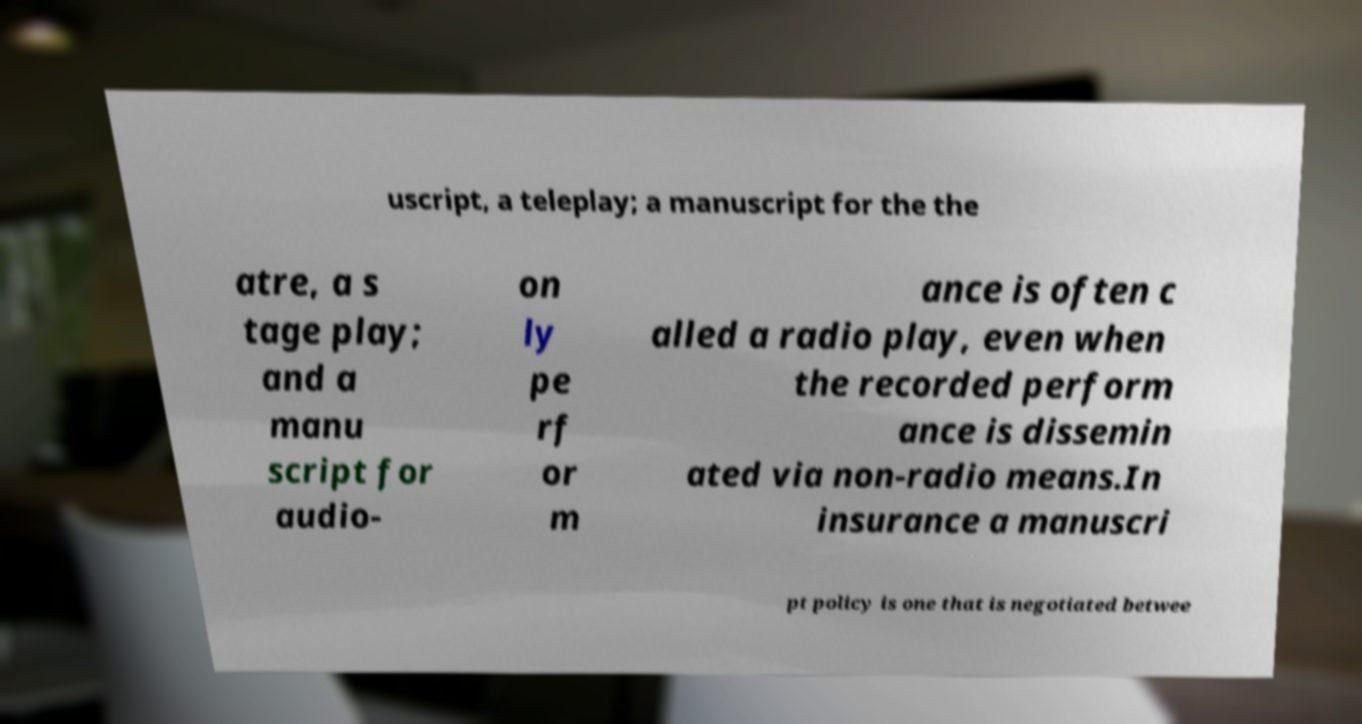There's text embedded in this image that I need extracted. Can you transcribe it verbatim? uscript, a teleplay; a manuscript for the the atre, a s tage play; and a manu script for audio- on ly pe rf or m ance is often c alled a radio play, even when the recorded perform ance is dissemin ated via non-radio means.In insurance a manuscri pt policy is one that is negotiated betwee 